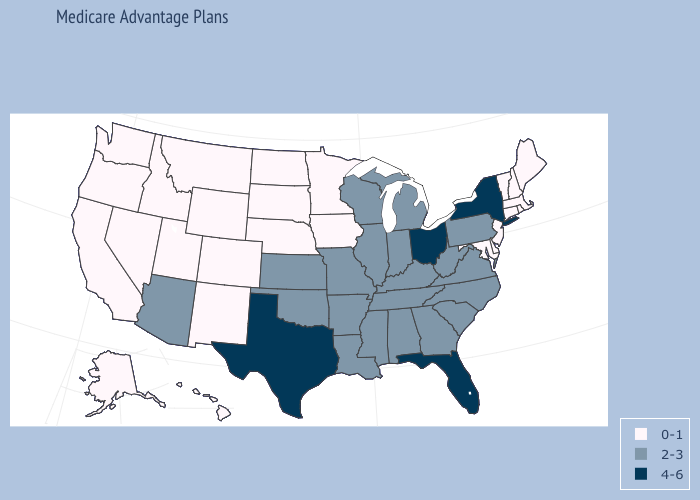What is the value of Rhode Island?
Give a very brief answer. 0-1. Does Idaho have a lower value than Connecticut?
Concise answer only. No. What is the highest value in states that border Utah?
Quick response, please. 2-3. Among the states that border Iowa , which have the highest value?
Answer briefly. Illinois, Missouri, Wisconsin. What is the value of Arizona?
Keep it brief. 2-3. Among the states that border Arkansas , which have the highest value?
Concise answer only. Texas. What is the highest value in the MidWest ?
Concise answer only. 4-6. Name the states that have a value in the range 2-3?
Quick response, please. Alabama, Arizona, Arkansas, Georgia, Illinois, Indiana, Kansas, Kentucky, Louisiana, Michigan, Mississippi, Missouri, North Carolina, Oklahoma, Pennsylvania, South Carolina, Tennessee, Virginia, West Virginia, Wisconsin. What is the highest value in states that border North Dakota?
Quick response, please. 0-1. Which states hav the highest value in the South?
Short answer required. Florida, Texas. Which states have the lowest value in the USA?
Concise answer only. Alaska, California, Colorado, Connecticut, Delaware, Hawaii, Idaho, Iowa, Maine, Maryland, Massachusetts, Minnesota, Montana, Nebraska, Nevada, New Hampshire, New Jersey, New Mexico, North Dakota, Oregon, Rhode Island, South Dakota, Utah, Vermont, Washington, Wyoming. Which states have the lowest value in the MidWest?
Write a very short answer. Iowa, Minnesota, Nebraska, North Dakota, South Dakota. What is the value of Nebraska?
Short answer required. 0-1. Which states have the lowest value in the USA?
Answer briefly. Alaska, California, Colorado, Connecticut, Delaware, Hawaii, Idaho, Iowa, Maine, Maryland, Massachusetts, Minnesota, Montana, Nebraska, Nevada, New Hampshire, New Jersey, New Mexico, North Dakota, Oregon, Rhode Island, South Dakota, Utah, Vermont, Washington, Wyoming. Is the legend a continuous bar?
Write a very short answer. No. 